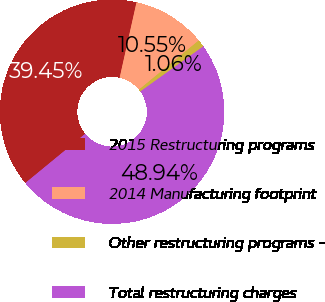Convert chart. <chart><loc_0><loc_0><loc_500><loc_500><pie_chart><fcel>2015 Restructuring programs<fcel>2014 Manufacturing footprint<fcel>Other restructuring programs -<fcel>Total restructuring charges<nl><fcel>39.45%<fcel>10.55%<fcel>1.06%<fcel>48.94%<nl></chart> 